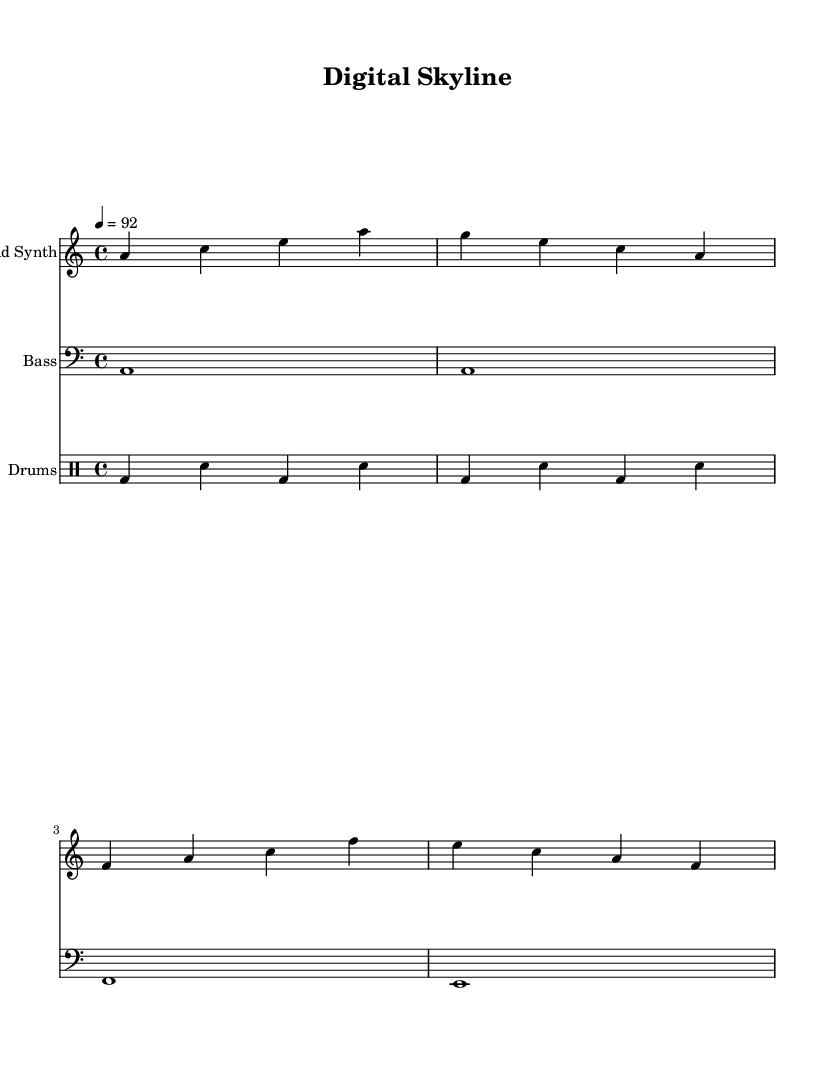What is the key signature of this music? The key signature is A minor, which consists of no sharps or flats. The first note in the lead synth part is A, indicating the tonal center is based on this note.
Answer: A minor What is the time signature of this piece? The time signature is 4/4, as indicated at the beginning of the score. This means there are four beats per measure, and a quarter note gets one beat.
Answer: 4/4 What is the tempo marking for the music? The tempo marking is 92 beats per minute, indicated by "4 = 92". This suggests a moderate tempo that guides the performance speed.
Answer: 92 What type of drum pattern is used in the music? The drum pattern consists of bass drum and snare hits alternating through the measures, which is characteristic of Hip Hop rhythms. The pattern is indicated in the drummode section.
Answer: Bass and snare How many measures are in the lead synth part? The lead synth part consists of four measures, each containing different melodic notes that contribute to the texture of the piece. The end of the lead synth section is indicated after four measures of music.
Answer: Four measures What lyrical theme is represented in the music? The lyrics mention "Sky -- scra -- pers rise, pix -- els in the sky," which suggests a theme of urban development and technology, resonating with the song title "Digital Skyline."
Answer: Urban development 